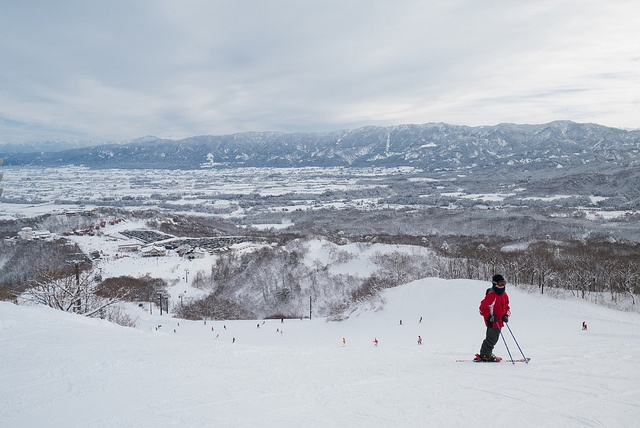Describe the objects in this image and their specific colors. I can see people in darkgray, black, brown, maroon, and lightgray tones, skis in darkgray, lightgray, lightpink, and gray tones, people in darkgray, lightgray, black, and purple tones, people in darkgray, lightgray, brown, and pink tones, and people in darkgray, lightgray, red, and pink tones in this image. 